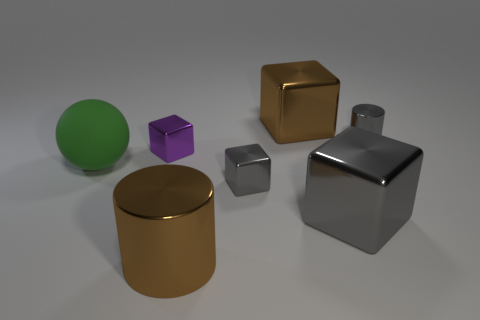Add 1 tiny purple metal things. How many objects exist? 8 Subtract all cylinders. How many objects are left? 5 Add 1 large green things. How many large green things are left? 2 Add 7 purple metal cubes. How many purple metal cubes exist? 8 Subtract 0 blue balls. How many objects are left? 7 Subtract all tiny red metal cylinders. Subtract all shiny cylinders. How many objects are left? 5 